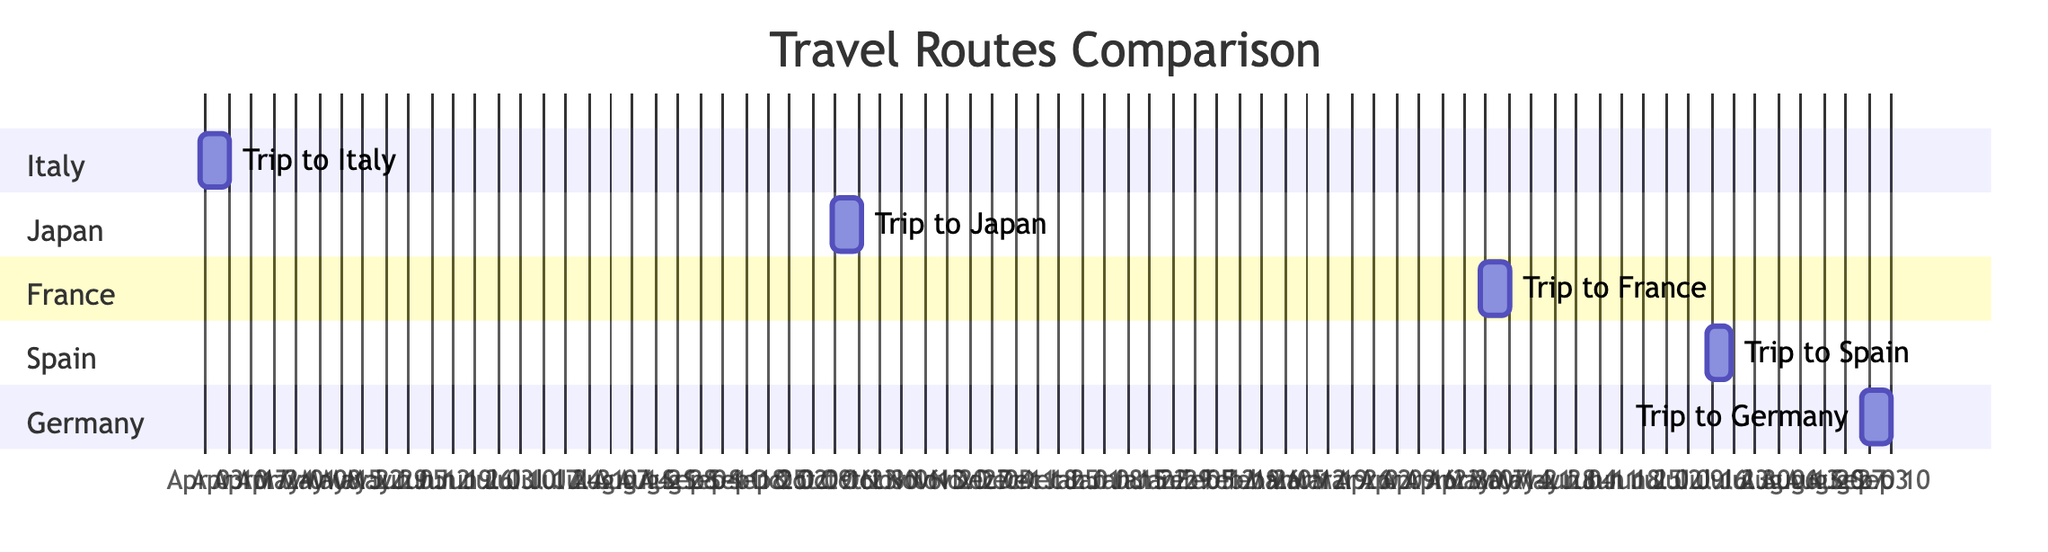What is the duration of the trip to Spain? The duration of the trip to Spain is listed directly in the diagram as 7 days.
Answer: 7 days What is the start date of the trip to Japan? The start date for the trip to Japan is shown in the diagram as October 15, 2022.
Answer: October 15, 2022 How many trips are shown in the diagram? The diagram displays a total of 5 trips, one for each destination listed.
Answer: 5 Which trip has the longest duration? By comparing the durations listed, the duration for Italy, Japan, France, and Germany is 9 days, while Spain's trip is 7 days. Therefore, the longest duration is 9 days for those trips (Italy, Japan, France, Germany).
Answer: 9 days What is the date range for the trip to Germany? By checking the diagram, the trip to Germany starts on September 1, 2023, and ends on September 10, 2023.
Answer: September 1, 2023 - September 10, 2023 How many travel routes overlap with the trip to Spain? The trip to Spain does not overlap with any trips, as it starts on July 15, 2023, and there are no trips starting before or ending after that date among the trips displayed.
Answer: 0 Which trip involved a historic site in the itinerary? The trip to Italy included the experience of exploring Rome's historic sites as part of its experiences, clearly shown in the diagram.
Answer: Italy What is the most recent trip mentioned in the diagram? The last trip listed in the diagram is to Germany, which takes place from September 1 to September 10, 2023, making it the most recent.
Answer: Germany What season do the trips to Japan and Spain fall in? The trip to Japan occurs in autumn (October), while the trip to Spain occurs in summer (July), as inferred from the dates in the diagram.
Answer: Autumn (Japan), Summer (Spain) 